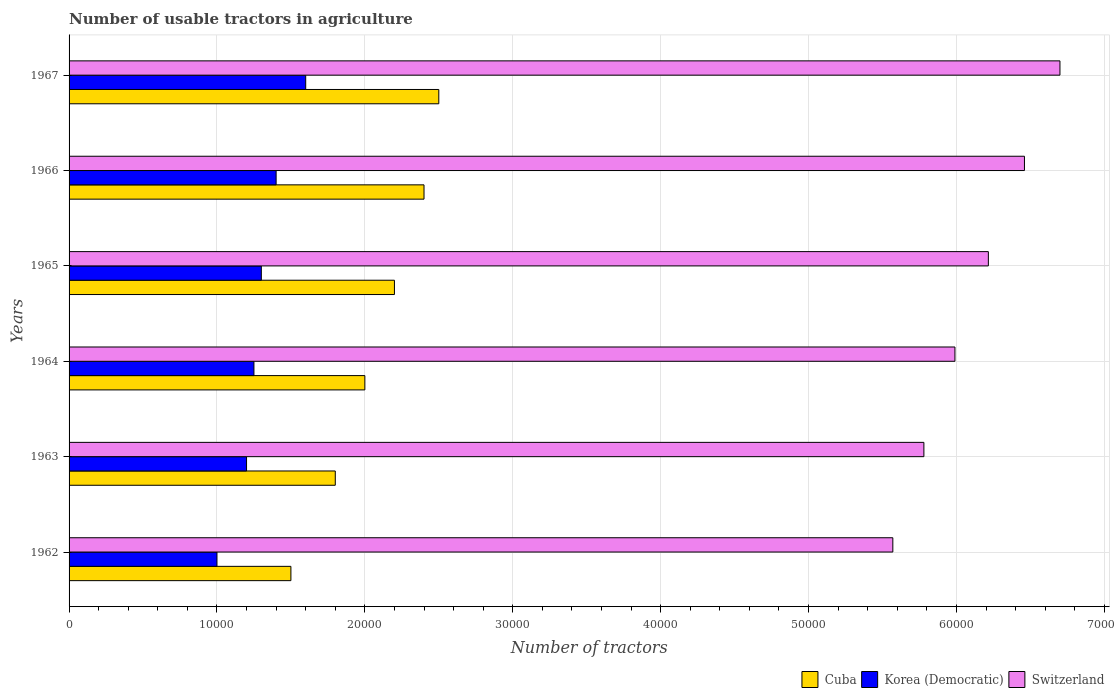How many different coloured bars are there?
Your answer should be very brief. 3. Are the number of bars per tick equal to the number of legend labels?
Offer a very short reply. Yes. Are the number of bars on each tick of the Y-axis equal?
Make the answer very short. Yes. How many bars are there on the 4th tick from the top?
Provide a short and direct response. 3. How many bars are there on the 4th tick from the bottom?
Give a very brief answer. 3. What is the label of the 4th group of bars from the top?
Provide a short and direct response. 1964. In how many cases, is the number of bars for a given year not equal to the number of legend labels?
Provide a short and direct response. 0. Across all years, what is the maximum number of usable tractors in agriculture in Korea (Democratic)?
Ensure brevity in your answer.  1.60e+04. Across all years, what is the minimum number of usable tractors in agriculture in Cuba?
Provide a short and direct response. 1.50e+04. In which year was the number of usable tractors in agriculture in Cuba maximum?
Offer a terse response. 1967. What is the total number of usable tractors in agriculture in Cuba in the graph?
Make the answer very short. 1.24e+05. What is the difference between the number of usable tractors in agriculture in Korea (Democratic) in 1963 and that in 1967?
Offer a very short reply. -4000. What is the difference between the number of usable tractors in agriculture in Korea (Democratic) in 1964 and the number of usable tractors in agriculture in Switzerland in 1963?
Offer a terse response. -4.53e+04. What is the average number of usable tractors in agriculture in Cuba per year?
Your response must be concise. 2.07e+04. In the year 1963, what is the difference between the number of usable tractors in agriculture in Korea (Democratic) and number of usable tractors in agriculture in Switzerland?
Your response must be concise. -4.58e+04. In how many years, is the number of usable tractors in agriculture in Cuba greater than 54000 ?
Give a very brief answer. 0. What is the ratio of the number of usable tractors in agriculture in Cuba in 1965 to that in 1967?
Offer a terse response. 0.88. Is the number of usable tractors in agriculture in Korea (Democratic) in 1966 less than that in 1967?
Your answer should be very brief. Yes. What is the difference between the highest and the lowest number of usable tractors in agriculture in Switzerland?
Keep it short and to the point. 1.13e+04. In how many years, is the number of usable tractors in agriculture in Cuba greater than the average number of usable tractors in agriculture in Cuba taken over all years?
Keep it short and to the point. 3. What does the 1st bar from the top in 1966 represents?
Make the answer very short. Switzerland. What does the 1st bar from the bottom in 1964 represents?
Keep it short and to the point. Cuba. Is it the case that in every year, the sum of the number of usable tractors in agriculture in Switzerland and number of usable tractors in agriculture in Cuba is greater than the number of usable tractors in agriculture in Korea (Democratic)?
Ensure brevity in your answer.  Yes. Are all the bars in the graph horizontal?
Ensure brevity in your answer.  Yes. How many years are there in the graph?
Provide a succinct answer. 6. What is the difference between two consecutive major ticks on the X-axis?
Ensure brevity in your answer.  10000. Are the values on the major ticks of X-axis written in scientific E-notation?
Your response must be concise. No. Does the graph contain any zero values?
Offer a very short reply. No. Where does the legend appear in the graph?
Your answer should be very brief. Bottom right. What is the title of the graph?
Provide a succinct answer. Number of usable tractors in agriculture. What is the label or title of the X-axis?
Your answer should be compact. Number of tractors. What is the label or title of the Y-axis?
Ensure brevity in your answer.  Years. What is the Number of tractors of Cuba in 1962?
Your response must be concise. 1.50e+04. What is the Number of tractors in Korea (Democratic) in 1962?
Offer a terse response. 10000. What is the Number of tractors in Switzerland in 1962?
Keep it short and to the point. 5.57e+04. What is the Number of tractors of Cuba in 1963?
Your answer should be compact. 1.80e+04. What is the Number of tractors of Korea (Democratic) in 1963?
Keep it short and to the point. 1.20e+04. What is the Number of tractors of Switzerland in 1963?
Your answer should be compact. 5.78e+04. What is the Number of tractors in Korea (Democratic) in 1964?
Keep it short and to the point. 1.25e+04. What is the Number of tractors of Switzerland in 1964?
Keep it short and to the point. 5.99e+04. What is the Number of tractors in Cuba in 1965?
Provide a short and direct response. 2.20e+04. What is the Number of tractors in Korea (Democratic) in 1965?
Provide a short and direct response. 1.30e+04. What is the Number of tractors of Switzerland in 1965?
Provide a short and direct response. 6.22e+04. What is the Number of tractors in Cuba in 1966?
Your answer should be very brief. 2.40e+04. What is the Number of tractors in Korea (Democratic) in 1966?
Keep it short and to the point. 1.40e+04. What is the Number of tractors in Switzerland in 1966?
Ensure brevity in your answer.  6.46e+04. What is the Number of tractors in Cuba in 1967?
Ensure brevity in your answer.  2.50e+04. What is the Number of tractors in Korea (Democratic) in 1967?
Make the answer very short. 1.60e+04. What is the Number of tractors in Switzerland in 1967?
Give a very brief answer. 6.70e+04. Across all years, what is the maximum Number of tractors of Cuba?
Offer a very short reply. 2.50e+04. Across all years, what is the maximum Number of tractors in Korea (Democratic)?
Offer a terse response. 1.60e+04. Across all years, what is the maximum Number of tractors in Switzerland?
Offer a terse response. 6.70e+04. Across all years, what is the minimum Number of tractors of Cuba?
Provide a short and direct response. 1.50e+04. Across all years, what is the minimum Number of tractors in Switzerland?
Provide a succinct answer. 5.57e+04. What is the total Number of tractors of Cuba in the graph?
Keep it short and to the point. 1.24e+05. What is the total Number of tractors of Korea (Democratic) in the graph?
Offer a terse response. 7.75e+04. What is the total Number of tractors of Switzerland in the graph?
Ensure brevity in your answer.  3.67e+05. What is the difference between the Number of tractors of Cuba in 1962 and that in 1963?
Give a very brief answer. -3000. What is the difference between the Number of tractors of Korea (Democratic) in 1962 and that in 1963?
Provide a succinct answer. -2000. What is the difference between the Number of tractors in Switzerland in 1962 and that in 1963?
Give a very brief answer. -2100. What is the difference between the Number of tractors of Cuba in 1962 and that in 1964?
Provide a succinct answer. -5000. What is the difference between the Number of tractors in Korea (Democratic) in 1962 and that in 1964?
Your answer should be compact. -2500. What is the difference between the Number of tractors in Switzerland in 1962 and that in 1964?
Your response must be concise. -4200. What is the difference between the Number of tractors in Cuba in 1962 and that in 1965?
Give a very brief answer. -7000. What is the difference between the Number of tractors of Korea (Democratic) in 1962 and that in 1965?
Make the answer very short. -3000. What is the difference between the Number of tractors of Switzerland in 1962 and that in 1965?
Keep it short and to the point. -6459. What is the difference between the Number of tractors in Cuba in 1962 and that in 1966?
Your answer should be very brief. -9000. What is the difference between the Number of tractors of Korea (Democratic) in 1962 and that in 1966?
Your response must be concise. -4000. What is the difference between the Number of tractors in Switzerland in 1962 and that in 1966?
Make the answer very short. -8900. What is the difference between the Number of tractors of Cuba in 1962 and that in 1967?
Your answer should be very brief. -10000. What is the difference between the Number of tractors in Korea (Democratic) in 1962 and that in 1967?
Your answer should be compact. -6000. What is the difference between the Number of tractors in Switzerland in 1962 and that in 1967?
Give a very brief answer. -1.13e+04. What is the difference between the Number of tractors of Cuba in 1963 and that in 1964?
Ensure brevity in your answer.  -2000. What is the difference between the Number of tractors in Korea (Democratic) in 1963 and that in 1964?
Ensure brevity in your answer.  -500. What is the difference between the Number of tractors of Switzerland in 1963 and that in 1964?
Make the answer very short. -2100. What is the difference between the Number of tractors in Cuba in 1963 and that in 1965?
Offer a very short reply. -4000. What is the difference between the Number of tractors in Korea (Democratic) in 1963 and that in 1965?
Your answer should be very brief. -1000. What is the difference between the Number of tractors in Switzerland in 1963 and that in 1965?
Your response must be concise. -4359. What is the difference between the Number of tractors of Cuba in 1963 and that in 1966?
Your answer should be very brief. -6000. What is the difference between the Number of tractors of Korea (Democratic) in 1963 and that in 1966?
Ensure brevity in your answer.  -2000. What is the difference between the Number of tractors in Switzerland in 1963 and that in 1966?
Provide a short and direct response. -6800. What is the difference between the Number of tractors in Cuba in 1963 and that in 1967?
Your answer should be very brief. -7000. What is the difference between the Number of tractors in Korea (Democratic) in 1963 and that in 1967?
Offer a very short reply. -4000. What is the difference between the Number of tractors in Switzerland in 1963 and that in 1967?
Provide a succinct answer. -9200. What is the difference between the Number of tractors in Cuba in 1964 and that in 1965?
Keep it short and to the point. -2000. What is the difference between the Number of tractors of Korea (Democratic) in 1964 and that in 1965?
Your answer should be compact. -500. What is the difference between the Number of tractors of Switzerland in 1964 and that in 1965?
Provide a short and direct response. -2259. What is the difference between the Number of tractors of Cuba in 1964 and that in 1966?
Your answer should be very brief. -4000. What is the difference between the Number of tractors in Korea (Democratic) in 1964 and that in 1966?
Provide a succinct answer. -1500. What is the difference between the Number of tractors of Switzerland in 1964 and that in 1966?
Your answer should be very brief. -4700. What is the difference between the Number of tractors in Cuba in 1964 and that in 1967?
Your answer should be compact. -5000. What is the difference between the Number of tractors of Korea (Democratic) in 1964 and that in 1967?
Provide a succinct answer. -3500. What is the difference between the Number of tractors of Switzerland in 1964 and that in 1967?
Ensure brevity in your answer.  -7100. What is the difference between the Number of tractors of Cuba in 1965 and that in 1966?
Ensure brevity in your answer.  -2000. What is the difference between the Number of tractors in Korea (Democratic) in 1965 and that in 1966?
Your answer should be very brief. -1000. What is the difference between the Number of tractors in Switzerland in 1965 and that in 1966?
Offer a very short reply. -2441. What is the difference between the Number of tractors of Cuba in 1965 and that in 1967?
Offer a terse response. -3000. What is the difference between the Number of tractors of Korea (Democratic) in 1965 and that in 1967?
Provide a short and direct response. -3000. What is the difference between the Number of tractors in Switzerland in 1965 and that in 1967?
Your response must be concise. -4841. What is the difference between the Number of tractors in Cuba in 1966 and that in 1967?
Your response must be concise. -1000. What is the difference between the Number of tractors in Korea (Democratic) in 1966 and that in 1967?
Provide a short and direct response. -2000. What is the difference between the Number of tractors in Switzerland in 1966 and that in 1967?
Provide a succinct answer. -2400. What is the difference between the Number of tractors of Cuba in 1962 and the Number of tractors of Korea (Democratic) in 1963?
Ensure brevity in your answer.  3000. What is the difference between the Number of tractors of Cuba in 1962 and the Number of tractors of Switzerland in 1963?
Provide a succinct answer. -4.28e+04. What is the difference between the Number of tractors in Korea (Democratic) in 1962 and the Number of tractors in Switzerland in 1963?
Provide a succinct answer. -4.78e+04. What is the difference between the Number of tractors of Cuba in 1962 and the Number of tractors of Korea (Democratic) in 1964?
Make the answer very short. 2500. What is the difference between the Number of tractors of Cuba in 1962 and the Number of tractors of Switzerland in 1964?
Provide a succinct answer. -4.49e+04. What is the difference between the Number of tractors in Korea (Democratic) in 1962 and the Number of tractors in Switzerland in 1964?
Provide a succinct answer. -4.99e+04. What is the difference between the Number of tractors of Cuba in 1962 and the Number of tractors of Korea (Democratic) in 1965?
Keep it short and to the point. 2000. What is the difference between the Number of tractors of Cuba in 1962 and the Number of tractors of Switzerland in 1965?
Offer a very short reply. -4.72e+04. What is the difference between the Number of tractors in Korea (Democratic) in 1962 and the Number of tractors in Switzerland in 1965?
Make the answer very short. -5.22e+04. What is the difference between the Number of tractors in Cuba in 1962 and the Number of tractors in Korea (Democratic) in 1966?
Make the answer very short. 1000. What is the difference between the Number of tractors in Cuba in 1962 and the Number of tractors in Switzerland in 1966?
Make the answer very short. -4.96e+04. What is the difference between the Number of tractors in Korea (Democratic) in 1962 and the Number of tractors in Switzerland in 1966?
Make the answer very short. -5.46e+04. What is the difference between the Number of tractors in Cuba in 1962 and the Number of tractors in Korea (Democratic) in 1967?
Offer a terse response. -1000. What is the difference between the Number of tractors in Cuba in 1962 and the Number of tractors in Switzerland in 1967?
Provide a succinct answer. -5.20e+04. What is the difference between the Number of tractors of Korea (Democratic) in 1962 and the Number of tractors of Switzerland in 1967?
Your response must be concise. -5.70e+04. What is the difference between the Number of tractors of Cuba in 1963 and the Number of tractors of Korea (Democratic) in 1964?
Keep it short and to the point. 5500. What is the difference between the Number of tractors in Cuba in 1963 and the Number of tractors in Switzerland in 1964?
Your answer should be compact. -4.19e+04. What is the difference between the Number of tractors in Korea (Democratic) in 1963 and the Number of tractors in Switzerland in 1964?
Ensure brevity in your answer.  -4.79e+04. What is the difference between the Number of tractors of Cuba in 1963 and the Number of tractors of Switzerland in 1965?
Keep it short and to the point. -4.42e+04. What is the difference between the Number of tractors of Korea (Democratic) in 1963 and the Number of tractors of Switzerland in 1965?
Your response must be concise. -5.02e+04. What is the difference between the Number of tractors of Cuba in 1963 and the Number of tractors of Korea (Democratic) in 1966?
Provide a short and direct response. 4000. What is the difference between the Number of tractors in Cuba in 1963 and the Number of tractors in Switzerland in 1966?
Provide a succinct answer. -4.66e+04. What is the difference between the Number of tractors in Korea (Democratic) in 1963 and the Number of tractors in Switzerland in 1966?
Offer a very short reply. -5.26e+04. What is the difference between the Number of tractors of Cuba in 1963 and the Number of tractors of Korea (Democratic) in 1967?
Your answer should be compact. 2000. What is the difference between the Number of tractors in Cuba in 1963 and the Number of tractors in Switzerland in 1967?
Make the answer very short. -4.90e+04. What is the difference between the Number of tractors in Korea (Democratic) in 1963 and the Number of tractors in Switzerland in 1967?
Your answer should be very brief. -5.50e+04. What is the difference between the Number of tractors of Cuba in 1964 and the Number of tractors of Korea (Democratic) in 1965?
Offer a terse response. 7000. What is the difference between the Number of tractors in Cuba in 1964 and the Number of tractors in Switzerland in 1965?
Keep it short and to the point. -4.22e+04. What is the difference between the Number of tractors of Korea (Democratic) in 1964 and the Number of tractors of Switzerland in 1965?
Your answer should be compact. -4.97e+04. What is the difference between the Number of tractors in Cuba in 1964 and the Number of tractors in Korea (Democratic) in 1966?
Your answer should be very brief. 6000. What is the difference between the Number of tractors in Cuba in 1964 and the Number of tractors in Switzerland in 1966?
Your response must be concise. -4.46e+04. What is the difference between the Number of tractors of Korea (Democratic) in 1964 and the Number of tractors of Switzerland in 1966?
Provide a succinct answer. -5.21e+04. What is the difference between the Number of tractors in Cuba in 1964 and the Number of tractors in Korea (Democratic) in 1967?
Your answer should be compact. 4000. What is the difference between the Number of tractors of Cuba in 1964 and the Number of tractors of Switzerland in 1967?
Offer a terse response. -4.70e+04. What is the difference between the Number of tractors of Korea (Democratic) in 1964 and the Number of tractors of Switzerland in 1967?
Make the answer very short. -5.45e+04. What is the difference between the Number of tractors of Cuba in 1965 and the Number of tractors of Korea (Democratic) in 1966?
Offer a very short reply. 8000. What is the difference between the Number of tractors in Cuba in 1965 and the Number of tractors in Switzerland in 1966?
Offer a very short reply. -4.26e+04. What is the difference between the Number of tractors of Korea (Democratic) in 1965 and the Number of tractors of Switzerland in 1966?
Your answer should be very brief. -5.16e+04. What is the difference between the Number of tractors in Cuba in 1965 and the Number of tractors in Korea (Democratic) in 1967?
Offer a terse response. 6000. What is the difference between the Number of tractors of Cuba in 1965 and the Number of tractors of Switzerland in 1967?
Provide a short and direct response. -4.50e+04. What is the difference between the Number of tractors in Korea (Democratic) in 1965 and the Number of tractors in Switzerland in 1967?
Your answer should be compact. -5.40e+04. What is the difference between the Number of tractors in Cuba in 1966 and the Number of tractors in Korea (Democratic) in 1967?
Offer a terse response. 8000. What is the difference between the Number of tractors of Cuba in 1966 and the Number of tractors of Switzerland in 1967?
Offer a very short reply. -4.30e+04. What is the difference between the Number of tractors of Korea (Democratic) in 1966 and the Number of tractors of Switzerland in 1967?
Give a very brief answer. -5.30e+04. What is the average Number of tractors of Cuba per year?
Make the answer very short. 2.07e+04. What is the average Number of tractors of Korea (Democratic) per year?
Keep it short and to the point. 1.29e+04. What is the average Number of tractors in Switzerland per year?
Your answer should be very brief. 6.12e+04. In the year 1962, what is the difference between the Number of tractors of Cuba and Number of tractors of Switzerland?
Your answer should be compact. -4.07e+04. In the year 1962, what is the difference between the Number of tractors in Korea (Democratic) and Number of tractors in Switzerland?
Make the answer very short. -4.57e+04. In the year 1963, what is the difference between the Number of tractors of Cuba and Number of tractors of Korea (Democratic)?
Offer a terse response. 6000. In the year 1963, what is the difference between the Number of tractors in Cuba and Number of tractors in Switzerland?
Your answer should be very brief. -3.98e+04. In the year 1963, what is the difference between the Number of tractors in Korea (Democratic) and Number of tractors in Switzerland?
Keep it short and to the point. -4.58e+04. In the year 1964, what is the difference between the Number of tractors in Cuba and Number of tractors in Korea (Democratic)?
Make the answer very short. 7500. In the year 1964, what is the difference between the Number of tractors in Cuba and Number of tractors in Switzerland?
Offer a terse response. -3.99e+04. In the year 1964, what is the difference between the Number of tractors in Korea (Democratic) and Number of tractors in Switzerland?
Your response must be concise. -4.74e+04. In the year 1965, what is the difference between the Number of tractors in Cuba and Number of tractors in Korea (Democratic)?
Keep it short and to the point. 9000. In the year 1965, what is the difference between the Number of tractors of Cuba and Number of tractors of Switzerland?
Your answer should be compact. -4.02e+04. In the year 1965, what is the difference between the Number of tractors in Korea (Democratic) and Number of tractors in Switzerland?
Provide a short and direct response. -4.92e+04. In the year 1966, what is the difference between the Number of tractors of Cuba and Number of tractors of Switzerland?
Provide a short and direct response. -4.06e+04. In the year 1966, what is the difference between the Number of tractors in Korea (Democratic) and Number of tractors in Switzerland?
Your answer should be compact. -5.06e+04. In the year 1967, what is the difference between the Number of tractors of Cuba and Number of tractors of Korea (Democratic)?
Your answer should be compact. 9000. In the year 1967, what is the difference between the Number of tractors of Cuba and Number of tractors of Switzerland?
Ensure brevity in your answer.  -4.20e+04. In the year 1967, what is the difference between the Number of tractors of Korea (Democratic) and Number of tractors of Switzerland?
Your answer should be very brief. -5.10e+04. What is the ratio of the Number of tractors of Cuba in 1962 to that in 1963?
Make the answer very short. 0.83. What is the ratio of the Number of tractors of Switzerland in 1962 to that in 1963?
Ensure brevity in your answer.  0.96. What is the ratio of the Number of tractors of Cuba in 1962 to that in 1964?
Your answer should be very brief. 0.75. What is the ratio of the Number of tractors in Switzerland in 1962 to that in 1964?
Offer a very short reply. 0.93. What is the ratio of the Number of tractors of Cuba in 1962 to that in 1965?
Provide a succinct answer. 0.68. What is the ratio of the Number of tractors of Korea (Democratic) in 1962 to that in 1965?
Offer a very short reply. 0.77. What is the ratio of the Number of tractors of Switzerland in 1962 to that in 1965?
Offer a very short reply. 0.9. What is the ratio of the Number of tractors of Switzerland in 1962 to that in 1966?
Make the answer very short. 0.86. What is the ratio of the Number of tractors in Cuba in 1962 to that in 1967?
Your response must be concise. 0.6. What is the ratio of the Number of tractors in Switzerland in 1962 to that in 1967?
Offer a terse response. 0.83. What is the ratio of the Number of tractors in Cuba in 1963 to that in 1964?
Give a very brief answer. 0.9. What is the ratio of the Number of tractors in Korea (Democratic) in 1963 to that in 1964?
Provide a short and direct response. 0.96. What is the ratio of the Number of tractors in Switzerland in 1963 to that in 1964?
Your answer should be compact. 0.96. What is the ratio of the Number of tractors of Cuba in 1963 to that in 1965?
Keep it short and to the point. 0.82. What is the ratio of the Number of tractors of Switzerland in 1963 to that in 1965?
Provide a succinct answer. 0.93. What is the ratio of the Number of tractors of Switzerland in 1963 to that in 1966?
Your answer should be compact. 0.89. What is the ratio of the Number of tractors in Cuba in 1963 to that in 1967?
Ensure brevity in your answer.  0.72. What is the ratio of the Number of tractors in Switzerland in 1963 to that in 1967?
Give a very brief answer. 0.86. What is the ratio of the Number of tractors in Korea (Democratic) in 1964 to that in 1965?
Give a very brief answer. 0.96. What is the ratio of the Number of tractors in Switzerland in 1964 to that in 1965?
Ensure brevity in your answer.  0.96. What is the ratio of the Number of tractors of Korea (Democratic) in 1964 to that in 1966?
Your answer should be compact. 0.89. What is the ratio of the Number of tractors of Switzerland in 1964 to that in 1966?
Make the answer very short. 0.93. What is the ratio of the Number of tractors in Cuba in 1964 to that in 1967?
Provide a short and direct response. 0.8. What is the ratio of the Number of tractors in Korea (Democratic) in 1964 to that in 1967?
Give a very brief answer. 0.78. What is the ratio of the Number of tractors of Switzerland in 1964 to that in 1967?
Keep it short and to the point. 0.89. What is the ratio of the Number of tractors in Cuba in 1965 to that in 1966?
Provide a short and direct response. 0.92. What is the ratio of the Number of tractors in Korea (Democratic) in 1965 to that in 1966?
Keep it short and to the point. 0.93. What is the ratio of the Number of tractors in Switzerland in 1965 to that in 1966?
Offer a very short reply. 0.96. What is the ratio of the Number of tractors of Cuba in 1965 to that in 1967?
Provide a short and direct response. 0.88. What is the ratio of the Number of tractors of Korea (Democratic) in 1965 to that in 1967?
Ensure brevity in your answer.  0.81. What is the ratio of the Number of tractors in Switzerland in 1965 to that in 1967?
Your response must be concise. 0.93. What is the ratio of the Number of tractors in Switzerland in 1966 to that in 1967?
Your answer should be compact. 0.96. What is the difference between the highest and the second highest Number of tractors of Cuba?
Ensure brevity in your answer.  1000. What is the difference between the highest and the second highest Number of tractors of Switzerland?
Ensure brevity in your answer.  2400. What is the difference between the highest and the lowest Number of tractors of Cuba?
Your answer should be compact. 10000. What is the difference between the highest and the lowest Number of tractors in Korea (Democratic)?
Provide a succinct answer. 6000. What is the difference between the highest and the lowest Number of tractors in Switzerland?
Ensure brevity in your answer.  1.13e+04. 